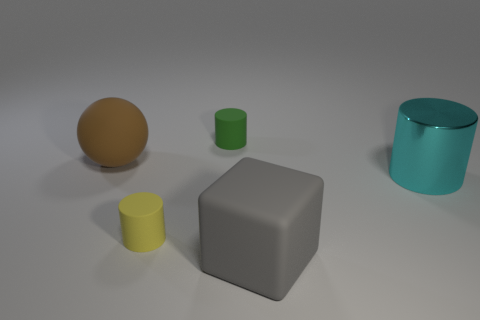Subtract all small cylinders. How many cylinders are left? 1 Add 5 matte cubes. How many objects exist? 10 Subtract all balls. How many objects are left? 4 Subtract all gray blocks. Subtract all large metal cylinders. How many objects are left? 3 Add 1 large gray cubes. How many large gray cubes are left? 2 Add 5 yellow rubber things. How many yellow rubber things exist? 6 Subtract 0 red balls. How many objects are left? 5 